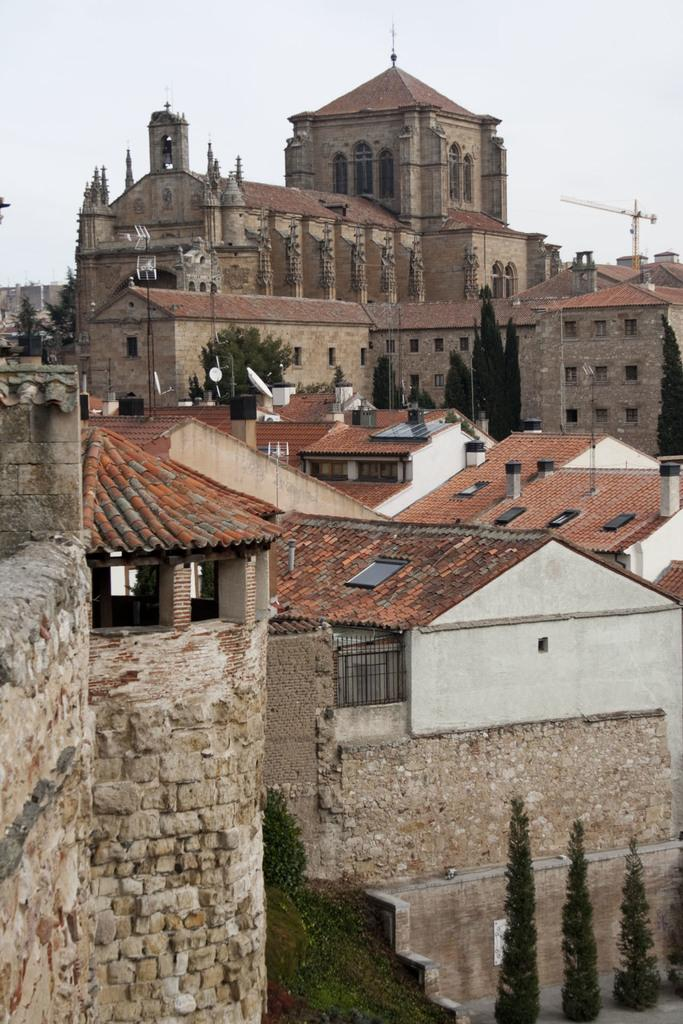What is the person in the image holding? The person is holding a guitar. What can be seen in the background of the image? There is a microphone stand in the background. What type of wax is being used to create the competition between the chairs in the image? There is no wax or competition between chairs present in the image; it features a person holding a guitar with a microphone stand in the background. 